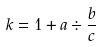Convert formula to latex. <formula><loc_0><loc_0><loc_500><loc_500>k = 1 + a \div \frac { b } { c }</formula> 